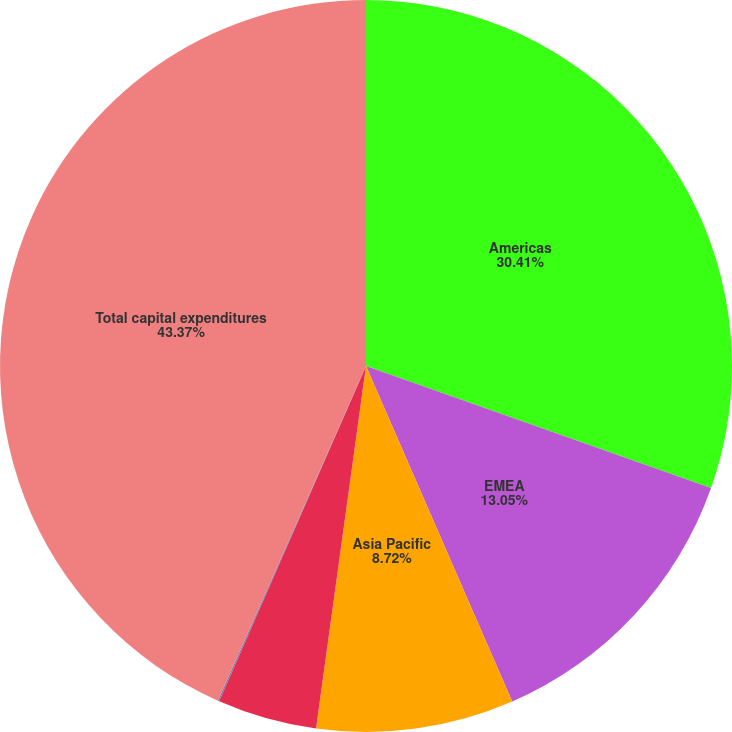<chart> <loc_0><loc_0><loc_500><loc_500><pie_chart><fcel>Americas<fcel>EMEA<fcel>Asia Pacific<fcel>Global Investment Management<fcel>Development Services<fcel>Total capital expenditures<nl><fcel>30.41%<fcel>13.05%<fcel>8.72%<fcel>4.39%<fcel>0.06%<fcel>43.37%<nl></chart> 